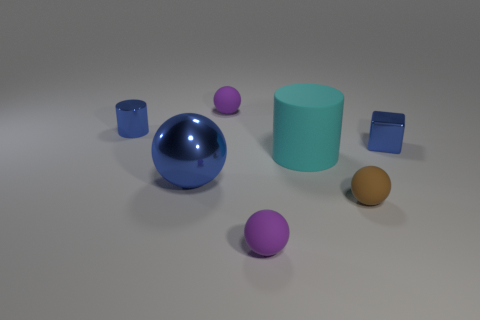What is the color of the small shiny thing behind the tiny shiny block?
Provide a short and direct response. Blue. There is a small shiny thing to the right of the blue cylinder; is there a purple rubber object in front of it?
Offer a very short reply. Yes. What number of other things are the same color as the large sphere?
Your response must be concise. 2. Do the purple sphere that is behind the blue metallic ball and the cylinder that is on the right side of the large blue metallic thing have the same size?
Ensure brevity in your answer.  No. How big is the cyan cylinder right of the blue object left of the blue ball?
Provide a short and direct response. Large. The tiny object that is both right of the large cyan rubber cylinder and in front of the matte cylinder is made of what material?
Provide a short and direct response. Rubber. What color is the rubber cylinder?
Offer a very short reply. Cyan. There is a small metallic thing behind the tiny block; what shape is it?
Offer a terse response. Cylinder. Is there a purple matte sphere that is in front of the tiny purple object to the left of the tiny purple sphere that is in front of the big blue shiny sphere?
Provide a short and direct response. Yes. Are there any big brown things?
Provide a short and direct response. No. 